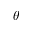<formula> <loc_0><loc_0><loc_500><loc_500>\theta</formula> 